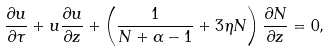<formula> <loc_0><loc_0><loc_500><loc_500>\frac { \partial u } { \partial \tau } + u \frac { \partial u } { \partial z } + \left ( \frac { 1 } { N + \alpha - 1 } + 3 \eta N \right ) \frac { \partial N } { \partial z } = 0 ,</formula> 